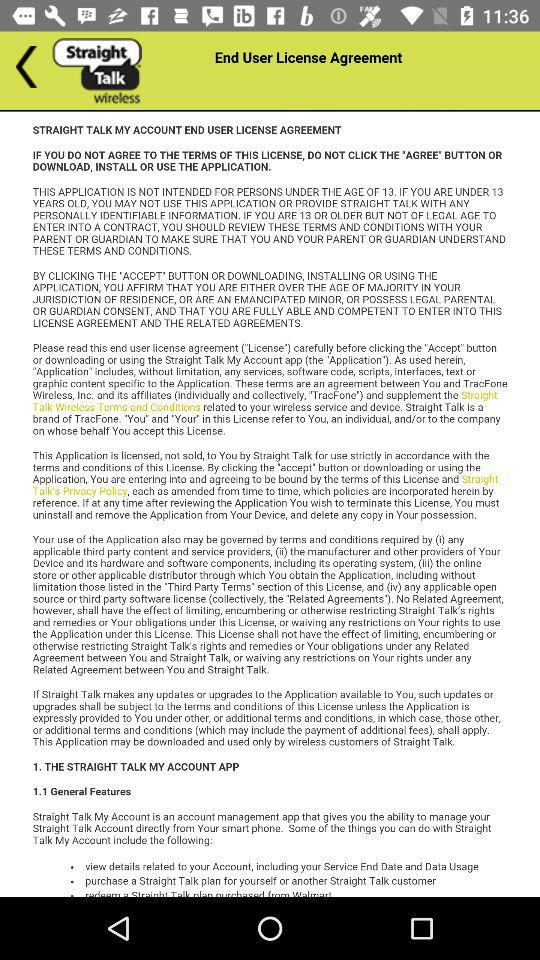What is the name of the application? The application name is "STRAIGHT TALK". 